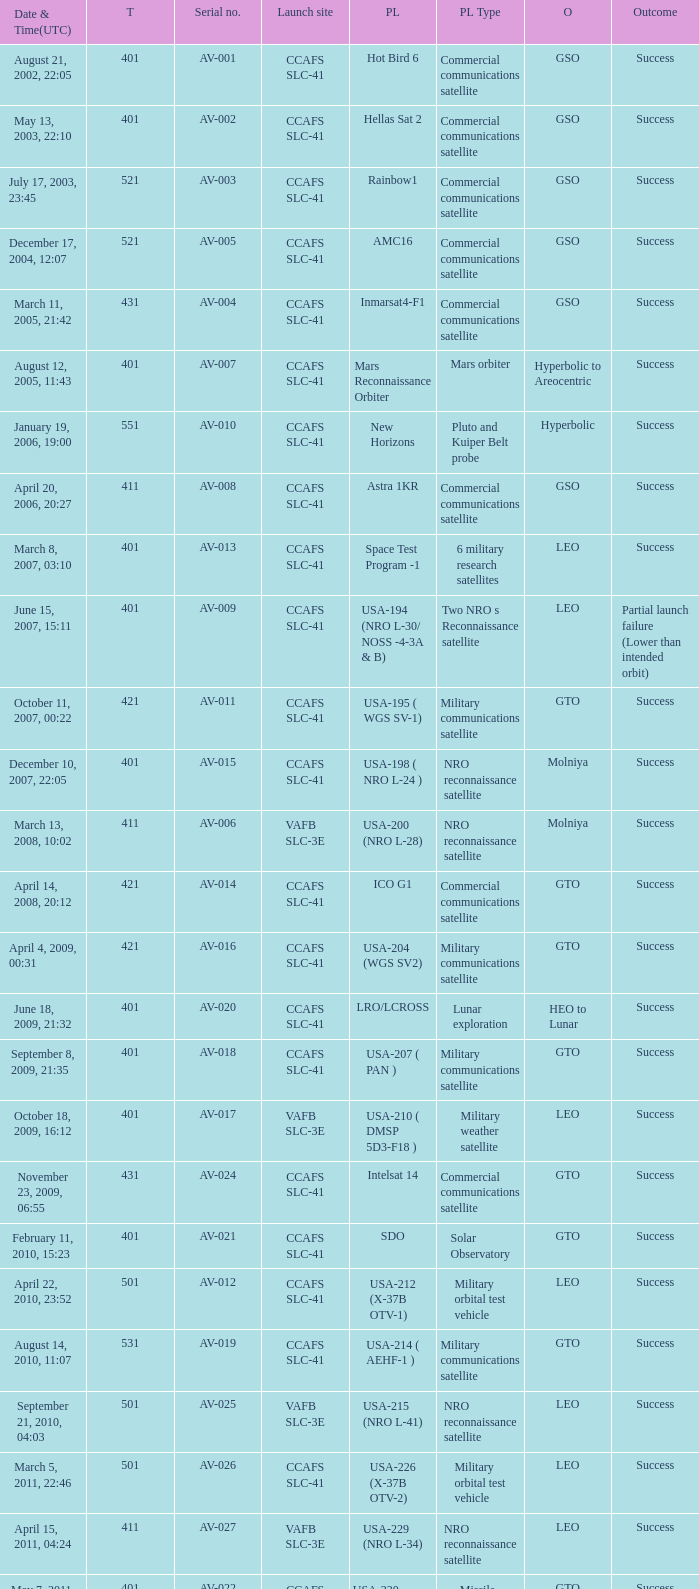For the payload of Van Allen Belts Exploration what's the serial number? AV-032. Can you give me this table as a dict? {'header': ['Date & Time(UTC)', 'T', 'Serial no.', 'Launch site', 'PL', 'PL Type', 'O', 'Outcome'], 'rows': [['August 21, 2002, 22:05', '401', 'AV-001', 'CCAFS SLC-41', 'Hot Bird 6', 'Commercial communications satellite', 'GSO', 'Success'], ['May 13, 2003, 22:10', '401', 'AV-002', 'CCAFS SLC-41', 'Hellas Sat 2', 'Commercial communications satellite', 'GSO', 'Success'], ['July 17, 2003, 23:45', '521', 'AV-003', 'CCAFS SLC-41', 'Rainbow1', 'Commercial communications satellite', 'GSO', 'Success'], ['December 17, 2004, 12:07', '521', 'AV-005', 'CCAFS SLC-41', 'AMC16', 'Commercial communications satellite', 'GSO', 'Success'], ['March 11, 2005, 21:42', '431', 'AV-004', 'CCAFS SLC-41', 'Inmarsat4-F1', 'Commercial communications satellite', 'GSO', 'Success'], ['August 12, 2005, 11:43', '401', 'AV-007', 'CCAFS SLC-41', 'Mars Reconnaissance Orbiter', 'Mars orbiter', 'Hyperbolic to Areocentric', 'Success'], ['January 19, 2006, 19:00', '551', 'AV-010', 'CCAFS SLC-41', 'New Horizons', 'Pluto and Kuiper Belt probe', 'Hyperbolic', 'Success'], ['April 20, 2006, 20:27', '411', 'AV-008', 'CCAFS SLC-41', 'Astra 1KR', 'Commercial communications satellite', 'GSO', 'Success'], ['March 8, 2007, 03:10', '401', 'AV-013', 'CCAFS SLC-41', 'Space Test Program -1', '6 military research satellites', 'LEO', 'Success'], ['June 15, 2007, 15:11', '401', 'AV-009', 'CCAFS SLC-41', 'USA-194 (NRO L-30/ NOSS -4-3A & B)', 'Two NRO s Reconnaissance satellite', 'LEO', 'Partial launch failure (Lower than intended orbit)'], ['October 11, 2007, 00:22', '421', 'AV-011', 'CCAFS SLC-41', 'USA-195 ( WGS SV-1)', 'Military communications satellite', 'GTO', 'Success'], ['December 10, 2007, 22:05', '401', 'AV-015', 'CCAFS SLC-41', 'USA-198 ( NRO L-24 )', 'NRO reconnaissance satellite', 'Molniya', 'Success'], ['March 13, 2008, 10:02', '411', 'AV-006', 'VAFB SLC-3E', 'USA-200 (NRO L-28)', 'NRO reconnaissance satellite', 'Molniya', 'Success'], ['April 14, 2008, 20:12', '421', 'AV-014', 'CCAFS SLC-41', 'ICO G1', 'Commercial communications satellite', 'GTO', 'Success'], ['April 4, 2009, 00:31', '421', 'AV-016', 'CCAFS SLC-41', 'USA-204 (WGS SV2)', 'Military communications satellite', 'GTO', 'Success'], ['June 18, 2009, 21:32', '401', 'AV-020', 'CCAFS SLC-41', 'LRO/LCROSS', 'Lunar exploration', 'HEO to Lunar', 'Success'], ['September 8, 2009, 21:35', '401', 'AV-018', 'CCAFS SLC-41', 'USA-207 ( PAN )', 'Military communications satellite', 'GTO', 'Success'], ['October 18, 2009, 16:12', '401', 'AV-017', 'VAFB SLC-3E', 'USA-210 ( DMSP 5D3-F18 )', 'Military weather satellite', 'LEO', 'Success'], ['November 23, 2009, 06:55', '431', 'AV-024', 'CCAFS SLC-41', 'Intelsat 14', 'Commercial communications satellite', 'GTO', 'Success'], ['February 11, 2010, 15:23', '401', 'AV-021', 'CCAFS SLC-41', 'SDO', 'Solar Observatory', 'GTO', 'Success'], ['April 22, 2010, 23:52', '501', 'AV-012', 'CCAFS SLC-41', 'USA-212 (X-37B OTV-1)', 'Military orbital test vehicle', 'LEO', 'Success'], ['August 14, 2010, 11:07', '531', 'AV-019', 'CCAFS SLC-41', 'USA-214 ( AEHF-1 )', 'Military communications satellite', 'GTO', 'Success'], ['September 21, 2010, 04:03', '501', 'AV-025', 'VAFB SLC-3E', 'USA-215 (NRO L-41)', 'NRO reconnaissance satellite', 'LEO', 'Success'], ['March 5, 2011, 22:46', '501', 'AV-026', 'CCAFS SLC-41', 'USA-226 (X-37B OTV-2)', 'Military orbital test vehicle', 'LEO', 'Success'], ['April 15, 2011, 04:24', '411', 'AV-027', 'VAFB SLC-3E', 'USA-229 (NRO L-34)', 'NRO reconnaissance satellite', 'LEO', 'Success'], ['May 7, 2011, 18:10', '401', 'AV-022', 'CCAFS SLC-41', 'USA-230 (SBIRS-GEO-1)', 'Missile Warning satellite', 'GTO', 'Success'], ['August 5, 2011, 16:25', '551', 'AV-029', 'CCAFS SLC-41', 'Juno', 'Jupiter orbiter', 'Hyperbolic to Jovicentric', 'Success'], ['November 26, 2011, 15:02', '541', 'AV-028', 'CCAFS SLC-41', 'Mars Science Laboratory', 'Mars rover', 'Hyperbolic (Mars landing)', 'Success'], ['February 24, 2012, 22:15', '551', 'AV-030', 'CCAFS SLC-41', 'MUOS-1', 'Military communications satellite', 'GTO', 'Success'], ['May 4, 2012, 18:42', '531', 'AV-031', 'CCAFS SLC-41', 'USA-235 ( AEHF-2 )', 'Military communications satellite', 'GTO', 'Success'], ['June 20, 2012, 12:28', '401', 'AV-023', 'CCAFS SLC-41', 'USA-236 (NROL-38)', 'NRO reconnaissance satellite', 'GEO', 'Success'], ['August 30, 2012, 08:05', '401', 'AV-032', 'CCAFS SLC-41', 'Van Allen Probes (RBSP)', 'Van Allen Belts exploration', 'MEO', 'Success'], ['September 13, 2012, 21:39', '401', 'AV-033', 'VAFB SLC-3E', 'USA-238 (NROL-36)', 'NRO reconnaissance satellites', 'LEO', 'Success'], ['December 11, 2012, 18:03', '501', 'AV-034', 'CCAFS SLC-41', 'USA-240 (X-37B OTV-3)', 'Military orbital test vehicle', 'LEO', 'Success'], ['January 31, 2013, 01:48', '401', 'AV-036', 'CCAFS SLC-41', 'TDRS-11 (TDRS-K)', 'Data relay satellite', 'GTO', 'Success'], ['February 11, 2013, 18:02', '401', 'AV-035', 'VAFB SLC-3E', 'Landsat 8', 'Earth Observation satellite', 'LEO', 'Success'], ['March 19, 2013, 21:21', '401', 'AV-037', 'CCAFS SLC-41', 'USA-241 ( SBIRS-GEO 2 )', 'Missile Warning satellite', 'GTO', 'Success'], ['May 15, 2013, 21:38', '401', 'AV-039', 'CCAFS SLC-41', 'USA-242 ( GPS IIF-4 )', 'Navigation satellite', 'MEO', 'Success'], ['July 19, 2013, 13:00', '551', 'AV-040', 'CCAFS SLC-41', 'MUOS-2', 'Military Communications satellite', 'GTO', 'Success'], ['September 18, 2013, 08:10', '531', 'AV-041', 'CCAFS SLC-41', 'USA-246 (AEHF-3)', 'Military communications satellite', 'GTO', 'Success']]} 